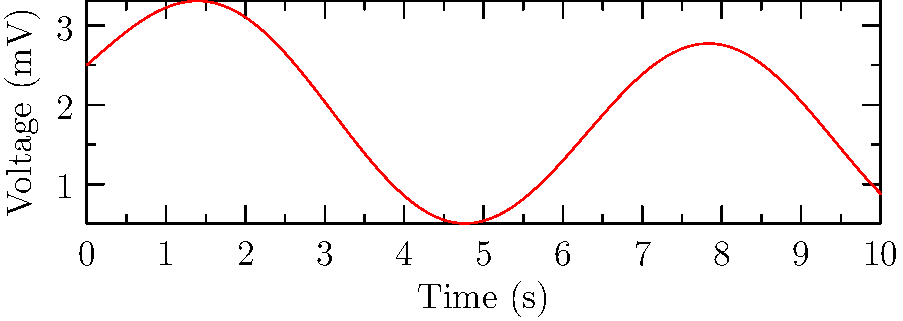As a biology major with a focus on gene therapy, you're analyzing an ECG waveform for a potential cardiac side effect in a gene therapy trial. The image shows a single cardiac cycle. What is the PR interval in this ECG, and what does it represent in terms of cardiac conduction? To answer this question, let's break it down step-by-step:

1. Identify the components of the ECG waveform:
   - P wave: Represents atrial depolarization
   - QRS complex: Represents ventricular depolarization
   - T wave: Represents ventricular repolarization

2. Locate the PR interval:
   - The PR interval starts at the beginning of the P wave and ends at the beginning of the QRS complex (specifically, the Q wave)

3. Measure the PR interval:
   - In this ECG, the PR interval appears to be approximately 0.16 seconds (assuming standard ECG paper speed of 25 mm/s)

4. Interpret the PR interval:
   - The PR interval represents the time taken for the electrical impulse to travel from the atria through the AV node to the ventricles
   - It reflects the conduction time through the atria, AV node, and His-Purkinje system

5. Normal PR interval:
   - A normal PR interval is typically between 0.12 and 0.20 seconds
   - The observed PR interval of 0.16 seconds falls within this normal range

6. Significance in gene therapy:
   - In gene therapy trials, monitoring the PR interval is crucial to detect any changes in cardiac conduction that might occur as a side effect of the treatment
   - An prolonged or shortened PR interval could indicate alterations in the heart's electrical system due to the gene therapy
Answer: The PR interval is approximately 0.16 seconds and represents the conduction time from atrial depolarization to the start of ventricular depolarization. 